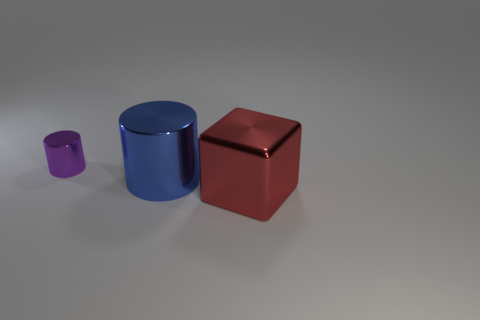Is there a brown cube that has the same material as the purple thing?
Offer a very short reply. No. There is a cylinder that is in front of the cylinder that is to the left of the blue cylinder; what is it made of?
Give a very brief answer. Metal. What size is the cylinder on the right side of the purple metal cylinder behind the metallic cylinder that is in front of the small thing?
Provide a short and direct response. Large. What number of other objects are the same shape as the large blue object?
Provide a succinct answer. 1. What color is the metallic cylinder that is the same size as the red shiny object?
Offer a terse response. Blue. There is a purple metallic object on the left side of the blue cylinder; is its size the same as the large blue shiny cylinder?
Make the answer very short. No. Is the number of red objects behind the red object the same as the number of large blue metal blocks?
Make the answer very short. Yes. How many objects are red blocks in front of the big blue shiny cylinder or cyan spheres?
Provide a short and direct response. 1. How many things are metal objects to the right of the big blue cylinder or metallic things that are on the right side of the purple shiny object?
Your answer should be very brief. 2. What number of other objects are the same size as the blue object?
Ensure brevity in your answer.  1. 